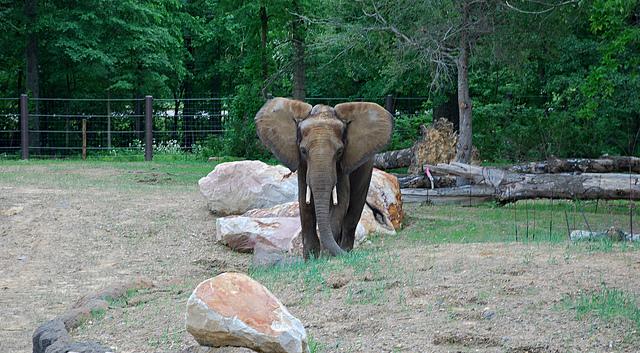Is the elephant enclosed by a fence?
Quick response, please. Yes. Which animal is this?
Answer briefly. Elephant. Is that a bear?
Be succinct. No. 